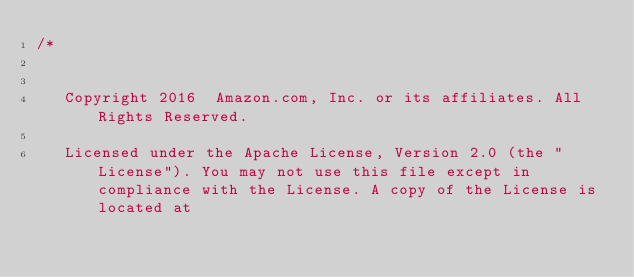Convert code to text. <code><loc_0><loc_0><loc_500><loc_500><_Cuda_>/*


   Copyright 2016  Amazon.com, Inc. or its affiliates. All Rights Reserved.

   Licensed under the Apache License, Version 2.0 (the "License"). You may not use this file except in compliance with the License. A copy of the License is located at
</code> 